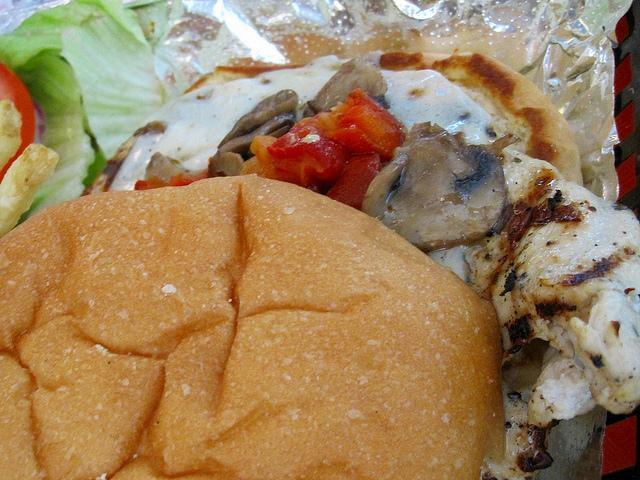How many burgers on the plate?
Give a very brief answer. 1. 